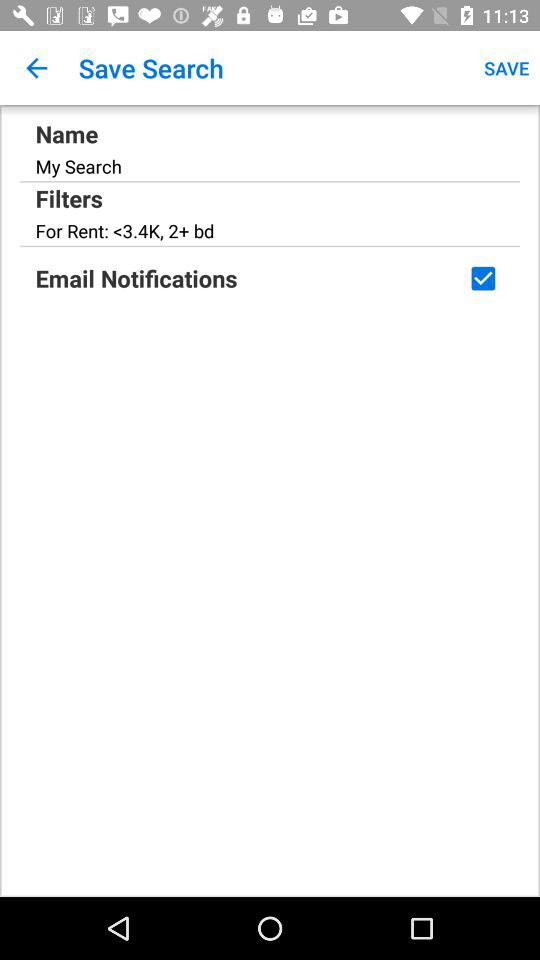What is the name? The name is "My Search". 